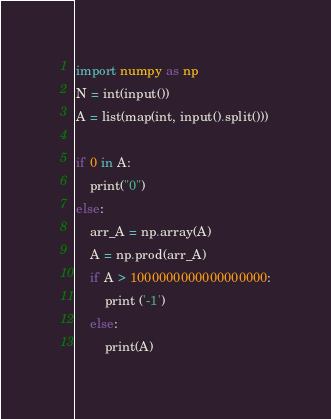<code> <loc_0><loc_0><loc_500><loc_500><_Python_>import numpy as np
N = int(input())
A = list(map(int, input().split()))

if 0 in A:
    print("0")
else:
    arr_A = np.array(A)
    A = np.prod(arr_A)
    if A > 1000000000000000000:
        print ('-1')
    else:
        print(A)</code> 